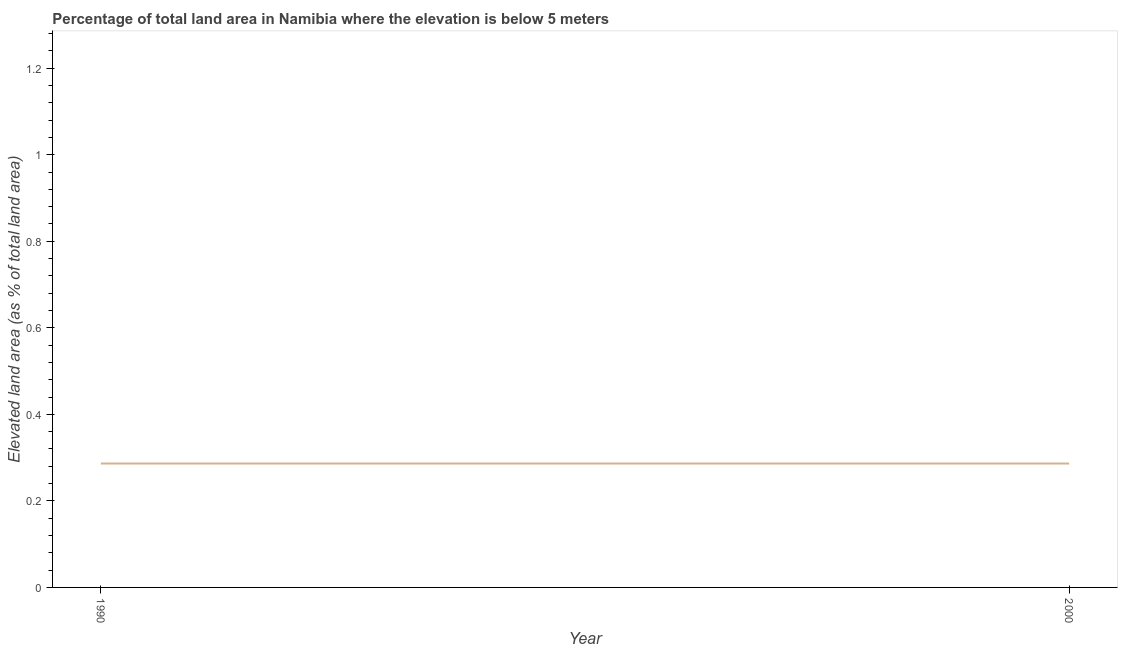What is the total elevated land area in 1990?
Provide a succinct answer. 0.29. Across all years, what is the maximum total elevated land area?
Ensure brevity in your answer.  0.29. Across all years, what is the minimum total elevated land area?
Your response must be concise. 0.29. What is the sum of the total elevated land area?
Ensure brevity in your answer.  0.57. What is the difference between the total elevated land area in 1990 and 2000?
Offer a terse response. 0. What is the average total elevated land area per year?
Make the answer very short. 0.29. What is the median total elevated land area?
Give a very brief answer. 0.29. Is the total elevated land area in 1990 less than that in 2000?
Offer a very short reply. No. Does the graph contain any zero values?
Your response must be concise. No. What is the title of the graph?
Your response must be concise. Percentage of total land area in Namibia where the elevation is below 5 meters. What is the label or title of the Y-axis?
Keep it short and to the point. Elevated land area (as % of total land area). What is the Elevated land area (as % of total land area) in 1990?
Your response must be concise. 0.29. What is the Elevated land area (as % of total land area) of 2000?
Offer a terse response. 0.29. 